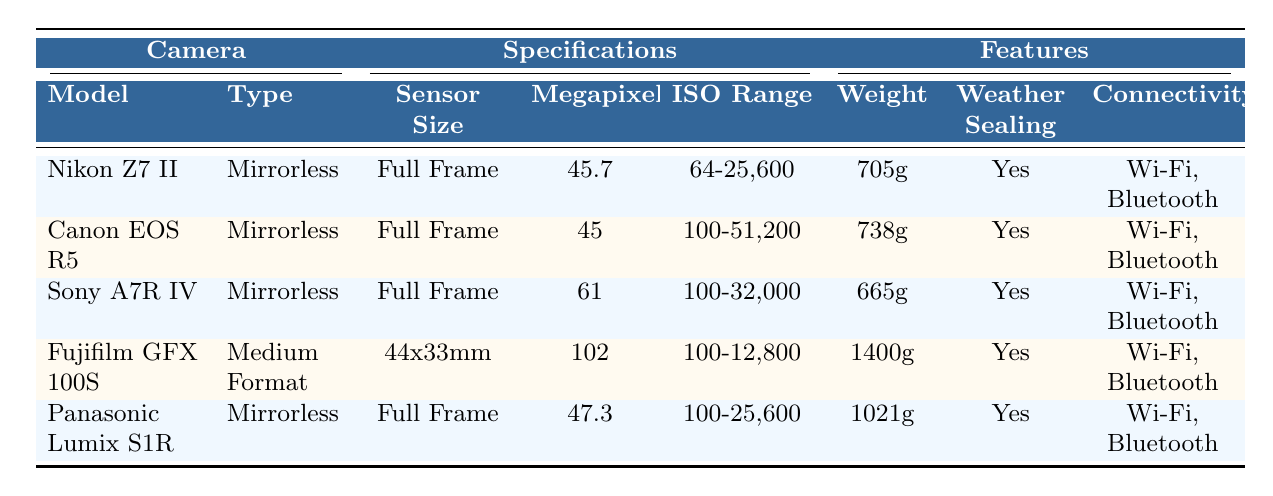What is the sensor size of the Canon EOS R5? The table shows that the sensor size for the Canon EOS R5 is listed under the "Specifications" section. It states "Full Frame" as the sensor size.
Answer: Full Frame Which camera has the highest megapixels? By examining the "Megapixels" column, the Fujifilm GFX 100S has 102 megapixels, which is the highest compared to the others in the table.
Answer: Fujifilm GFX 100S Is the Sony A7R IV weather sealed? The "Weather Sealing" column indicates "Yes" for the Sony A7R IV, confirming it has weather sealing.
Answer: Yes What is the weight difference between the Nikon Z7 II and the Panasonic Lumix S1R? The weight of the Nikon Z7 II is 705g and the Panasonic Lumix S1R is 1021g. The difference is calculated as 1021g - 705g = 316g.
Answer: 316g What is the average ISO range of the cameras listed? The ISO ranges are: Nikon Z7 II (64-25,600), Canon EOS R5 (100-51,200), Sony A7R IV (100-32,000), Fujifilm GFX 100S (100-12,800), and Panasonic Lumix S1R (100-25,600). Taking the average of the lower ends: (64 + 100 + 100 + 100 + 100) / 5 = 92.8 and the average of the upper ends: (25,600 + 51,200 + 32,000 + 12,800 + 25,600) / 5 = 29,840. The average ISO range is approximately 92.8 to 29,840.
Answer: 92.8 to 29,840 Which camera has the lowest weight but still has full weather sealing? Looking at the "Weight" and "Weather Sealing" columns, the Sony A7R IV weighs 665g and confirms that it also features weather sealing.
Answer: Sony A7R IV How many cameras in the table are mirrorless? The table lists a total of 5 cameras: 4 are mirrorless (Nikon Z7 II, Canon EOS R5, Sony A7R IV, Panasonic Lumix S1R) and 1 is medium format (Fujifilm GFX 100S). Thus, 4 out of 5 are mirrorless.
Answer: 4 What is the total number of megapixels for all cameras? The megapixels are: Nikon Z7 II (45.7), Canon EOS R5 (45), Sony A7R IV (61), Fujifilm GFX 100S (102), and Panasonic Lumix S1R (47.3). Summing these yields 45.7 + 45 + 61 + 102 + 47.3 = 301.
Answer: 301 Is it possible to find a camera in the table with Medium Format and full weather sealing? The Fujifilm GFX 100S is the only camera with a Medium Format sensor, and it is listed as having weather sealing ("Yes"). Thus, it meets these criteria.
Answer: Yes Which camera has the largest ISO range? The Canon EOS R5 has an ISO range of 100-51,200, which is the highest among the cameras listed in the table compared to others.
Answer: Canon EOS R5 